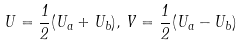<formula> <loc_0><loc_0><loc_500><loc_500>U = \frac { 1 } { 2 } ( U _ { a } + U _ { b } ) \/ , \, V = \frac { 1 } { 2 } ( U _ { a } - U _ { b } )</formula> 